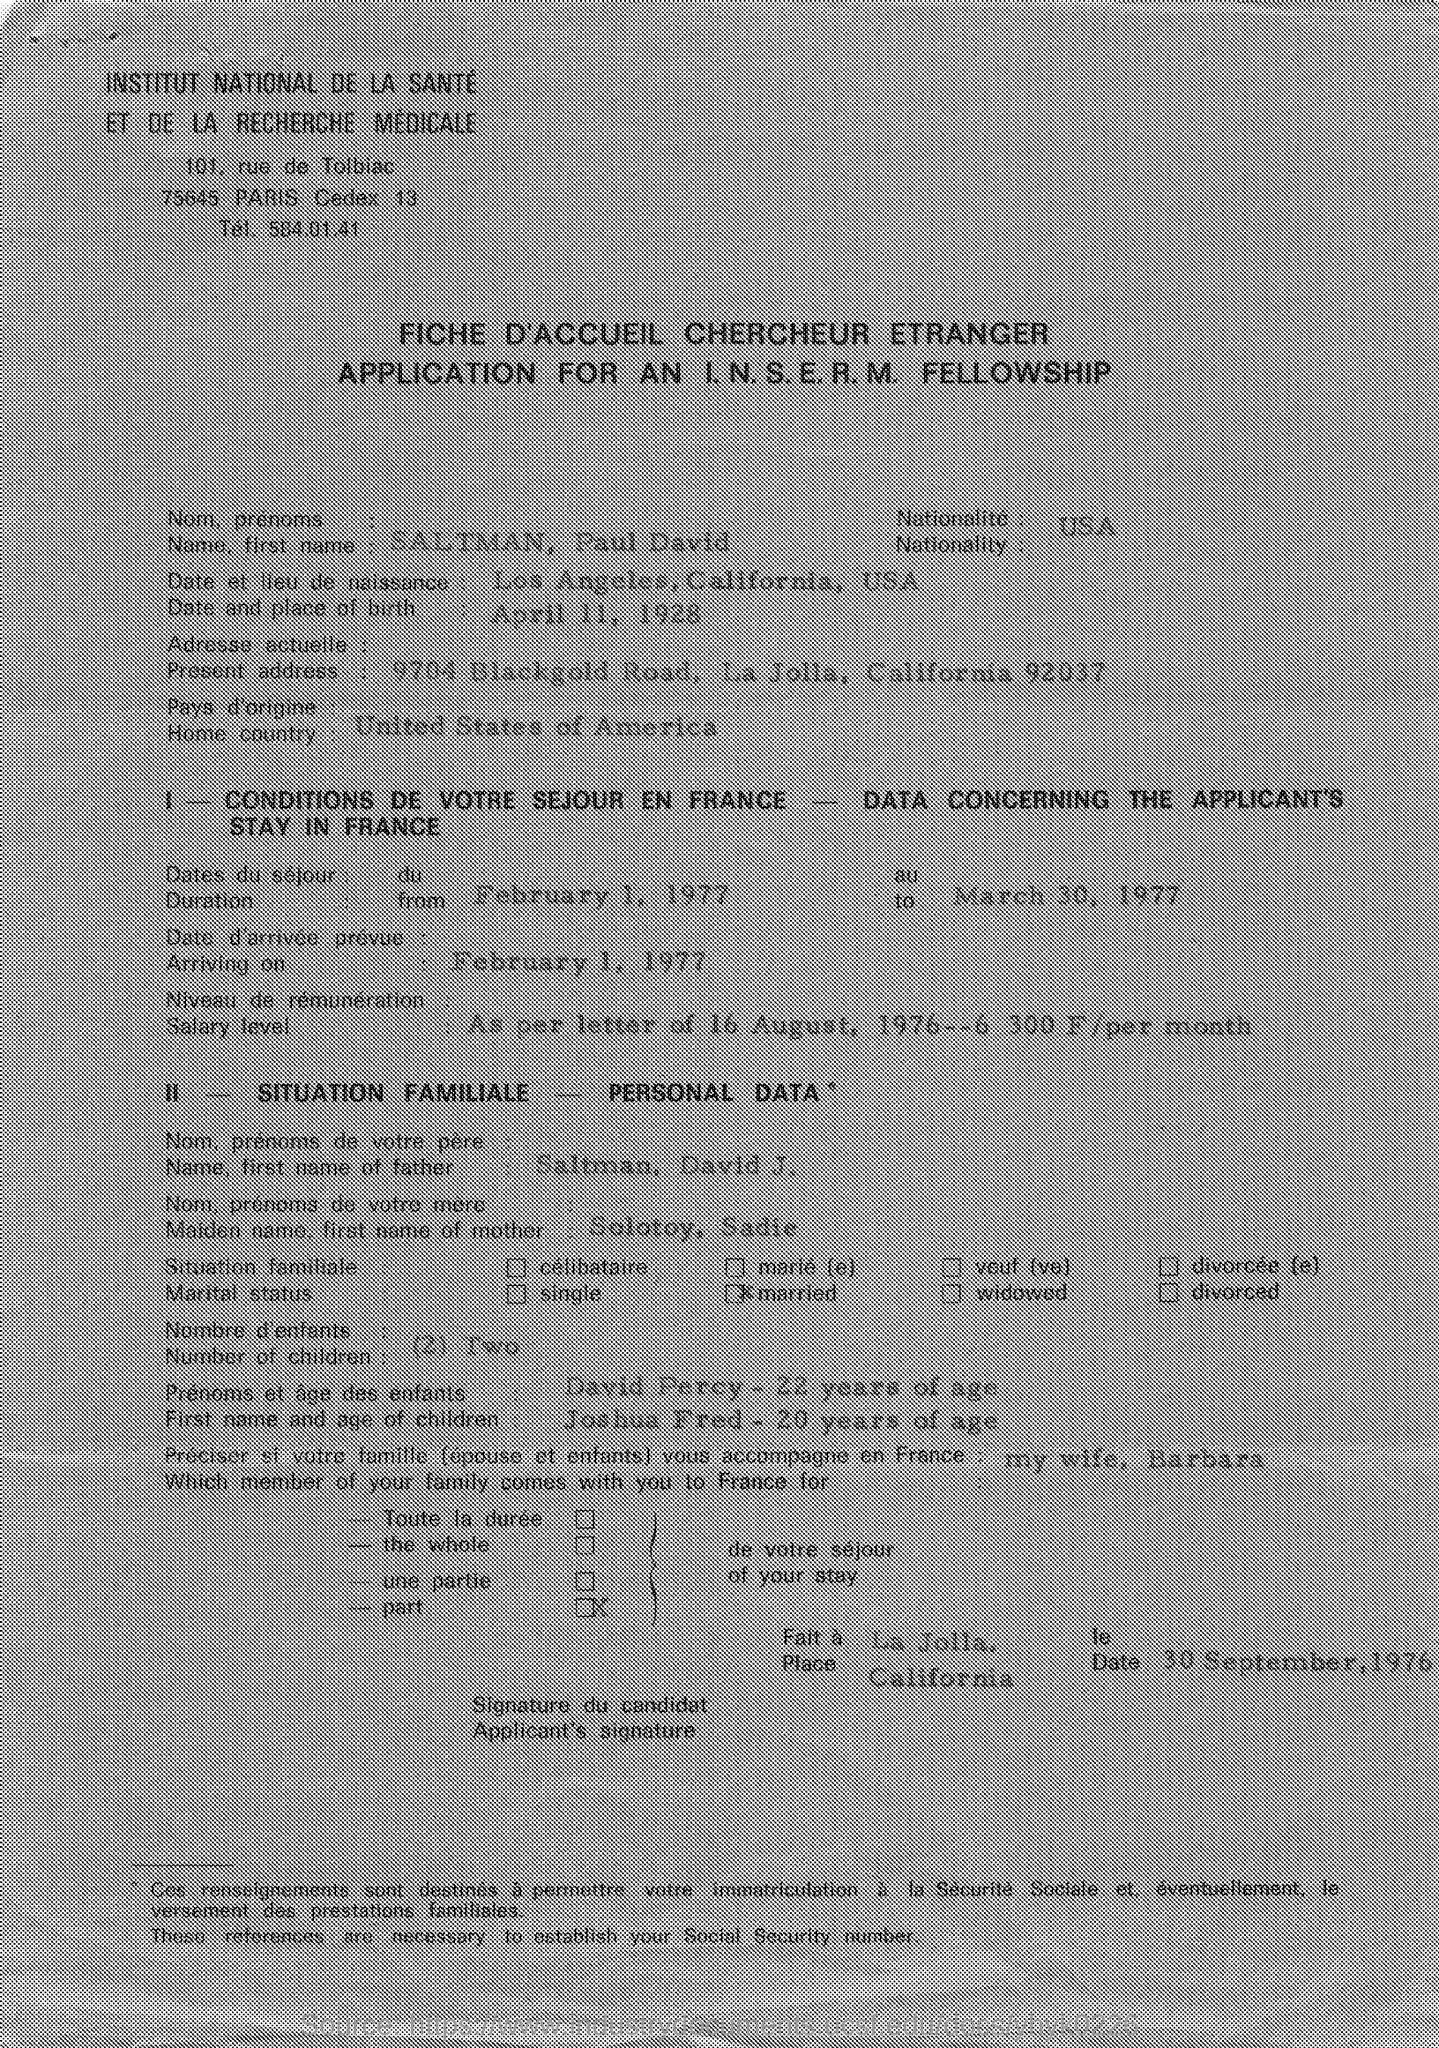What is the name , first name mentioned in the given application ?
Your response must be concise. SALTMAN, PAUL DAVID. What is the nationality mentioned in the given application ?
Your answer should be compact. USA. What is the home country mentioned in the given application ?
Give a very brief answer. UNITED STATES OF AMERICA. What is the present address mentioned in the given application ?
Your answer should be very brief. 9704 Blackgold road, La Jolla, California 92037. What is the name , first name of father mentioned in the given application ?
Offer a very short reply. SALTMAN, DAVID J. What is the maiden name, first name of mother as mentioned in the given application ?
Keep it short and to the point. Solotoy, Sadie. What is the arriving date mentioned in the given application ?
Keep it short and to the point. FEBRUARY 1, 1977. 